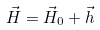<formula> <loc_0><loc_0><loc_500><loc_500>\vec { H } = \vec { H } _ { 0 } + \vec { h }</formula> 